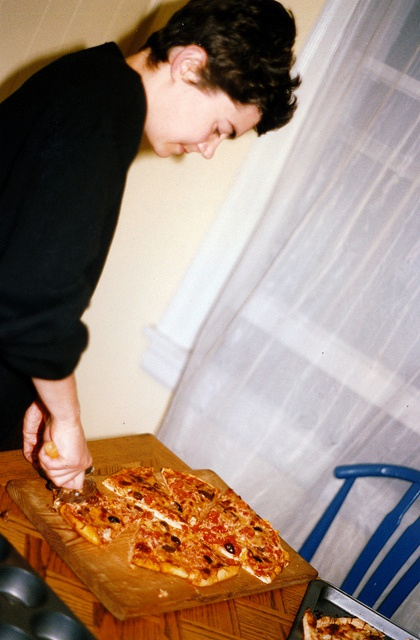Describe the objects in this image and their specific colors. I can see people in tan, black, and lightgray tones, pizza in tan, red, brown, and orange tones, dining table in tan, brown, and maroon tones, chair in tan, navy, gray, and darkblue tones, and pizza in tan, red, maroon, and black tones in this image. 